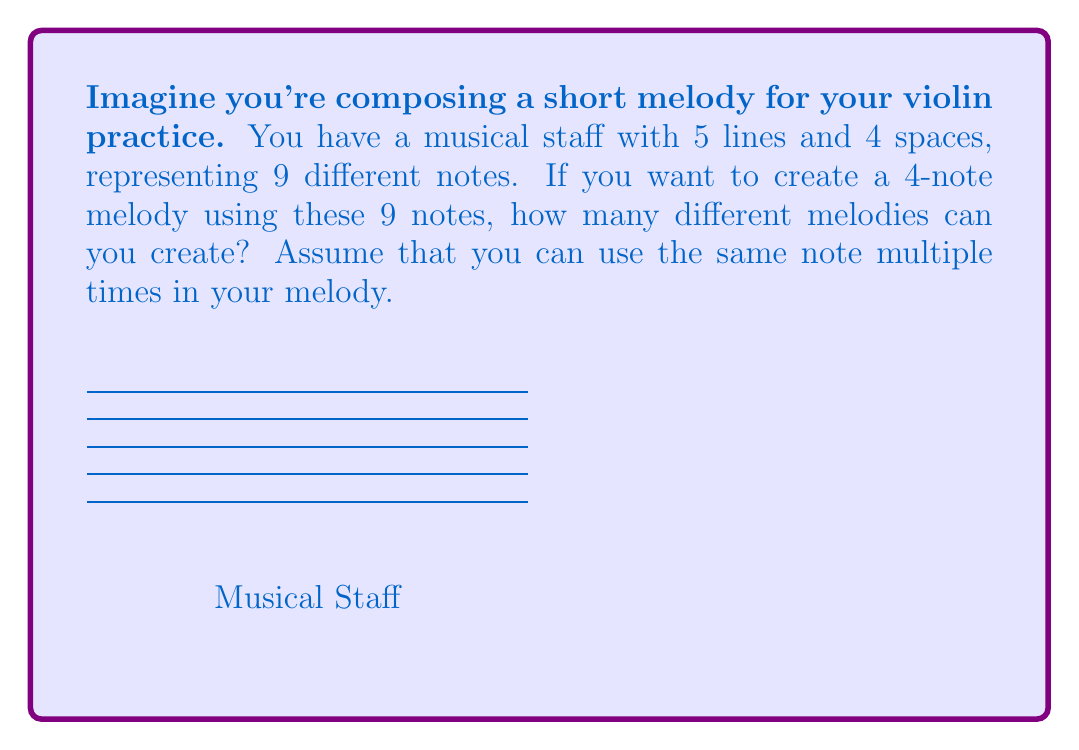Provide a solution to this math problem. Let's approach this step-by-step:

1) First, we need to understand what the question is asking. We have:
   - 9 different notes to choose from
   - We need to create a melody with 4 notes
   - We can use the same note multiple times

2) This scenario is a perfect example of the multiplication principle in combinatorics. 
   For each position in our 4-note melody, we have 9 choices.

3) Let's break it down:
   - For the 1st note: we have 9 choices
   - For the 2nd note: we again have 9 choices (because we can reuse notes)
   - For the 3rd note: again 9 choices
   - For the 4th note: again 9 choices

4) According to the multiplication principle, when we have independent choices, 
   we multiply the number of possibilities for each choice.

5) Therefore, the total number of possible melodies is:

   $$ 9 \times 9 \times 9 \times 9 = 9^4 = 6,561 $$

This means you can create 6,561 different 4-note melodies using the 9 notes on your staff!
Answer: $9^4 = 6,561$ 